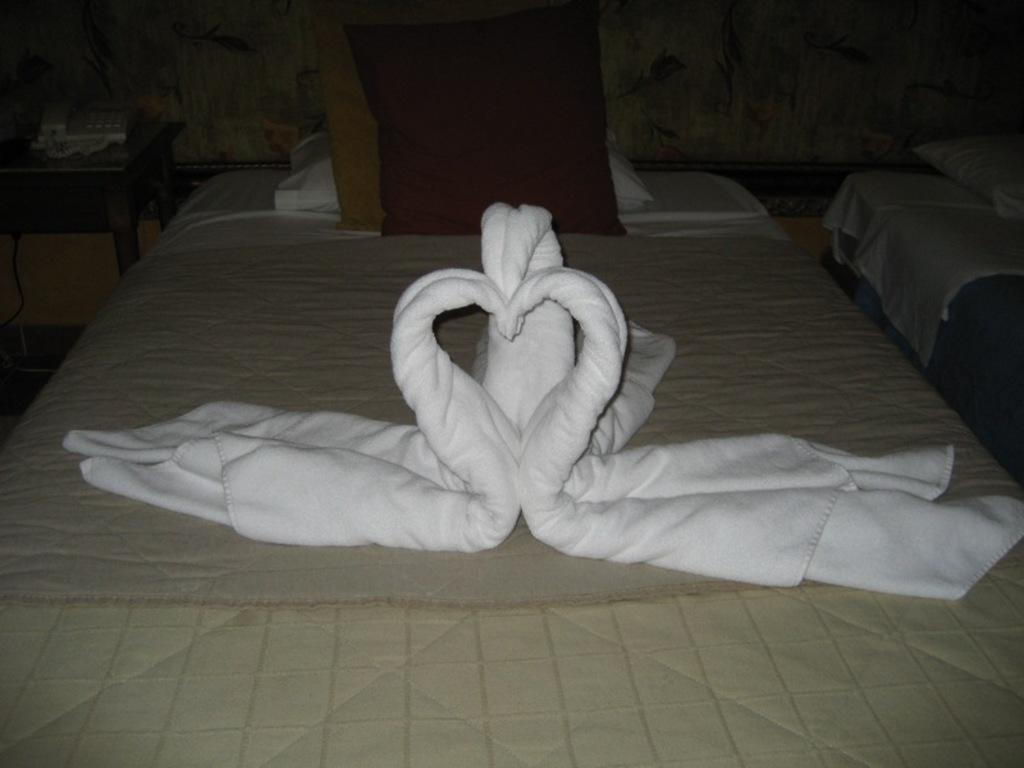What object can be seen on a table in the background of the image? There is a telephone on a table in the background of the image. What type of furniture is present in the image? There are beds with mattresses and pillows in the image. What type of decoration is visible in the image? There is some art visible in the image. What type of linens are present in the image? White towels are present in the image. What flavor of ice cream is being served at the show in the image? There is no ice cream or show present in the image; it features a telephone on a table, beds with mattresses and pillows, art, and white towels. How does the sun affect the art in the image? The image does not show any sun or its effects on the art; it only shows the art itself. 